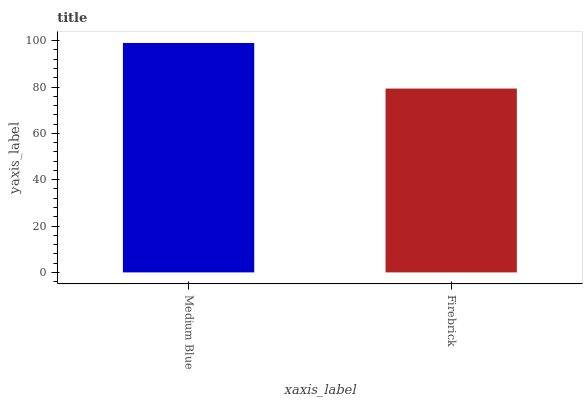Is Firebrick the minimum?
Answer yes or no. Yes. Is Medium Blue the maximum?
Answer yes or no. Yes. Is Firebrick the maximum?
Answer yes or no. No. Is Medium Blue greater than Firebrick?
Answer yes or no. Yes. Is Firebrick less than Medium Blue?
Answer yes or no. Yes. Is Firebrick greater than Medium Blue?
Answer yes or no. No. Is Medium Blue less than Firebrick?
Answer yes or no. No. Is Medium Blue the high median?
Answer yes or no. Yes. Is Firebrick the low median?
Answer yes or no. Yes. Is Firebrick the high median?
Answer yes or no. No. Is Medium Blue the low median?
Answer yes or no. No. 